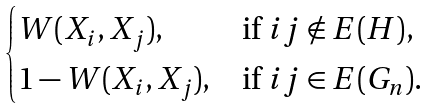<formula> <loc_0><loc_0><loc_500><loc_500>\begin{cases} W ( X _ { i } , X _ { j } ) , & \text {if $ij\notin E(H)$} , \\ 1 - W ( X _ { i } , X _ { j } ) , & \text {if $ij\in E(G_{n})$} . \end{cases}</formula> 